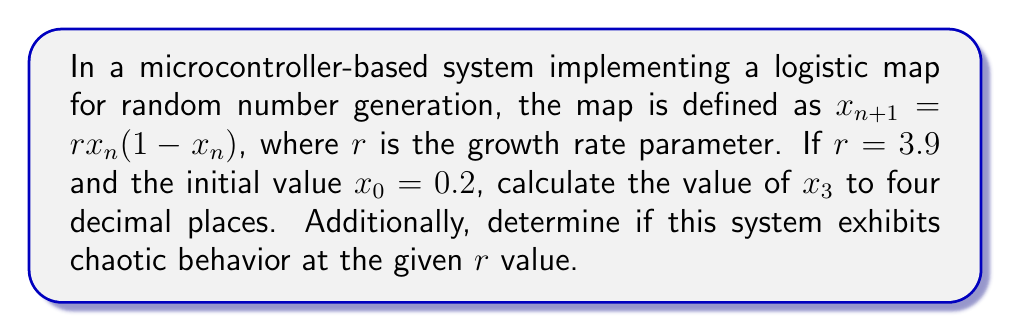Can you solve this math problem? 1. The logistic map is defined as:
   $$x_{n+1} = rx_n(1-x_n)$$
   where $r = 3.9$ and $x_0 = 0.2$

2. Calculate $x_1$:
   $$x_1 = 3.9 \cdot 0.2 \cdot (1-0.2) = 3.9 \cdot 0.2 \cdot 0.8 = 0.624$$

3. Calculate $x_2$:
   $$x_2 = 3.9 \cdot 0.624 \cdot (1-0.624) = 3.9 \cdot 0.624 \cdot 0.376 = 0.9165984$$

4. Calculate $x_3$:
   $$x_3 = 3.9 \cdot 0.9165984 \cdot (1-0.9165984) = 3.9 \cdot 0.9165984 \cdot 0.0834016 = 0.2978$$

5. Round $x_3$ to four decimal places: 0.2978

6. To determine if the system exhibits chaotic behavior:
   - Chaotic behavior in the logistic map occurs when $r > 3.57$ approximately.
   - Since $r = 3.9 > 3.57$, the system does exhibit chaotic behavior.
Answer: $x_3 = 0.2978$; The system exhibits chaotic behavior. 